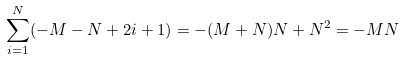Convert formula to latex. <formula><loc_0><loc_0><loc_500><loc_500>\sum _ { i = 1 } ^ { N } ( - M - N + 2 i + 1 ) = - ( M + N ) N + N ^ { 2 } = - M N</formula> 